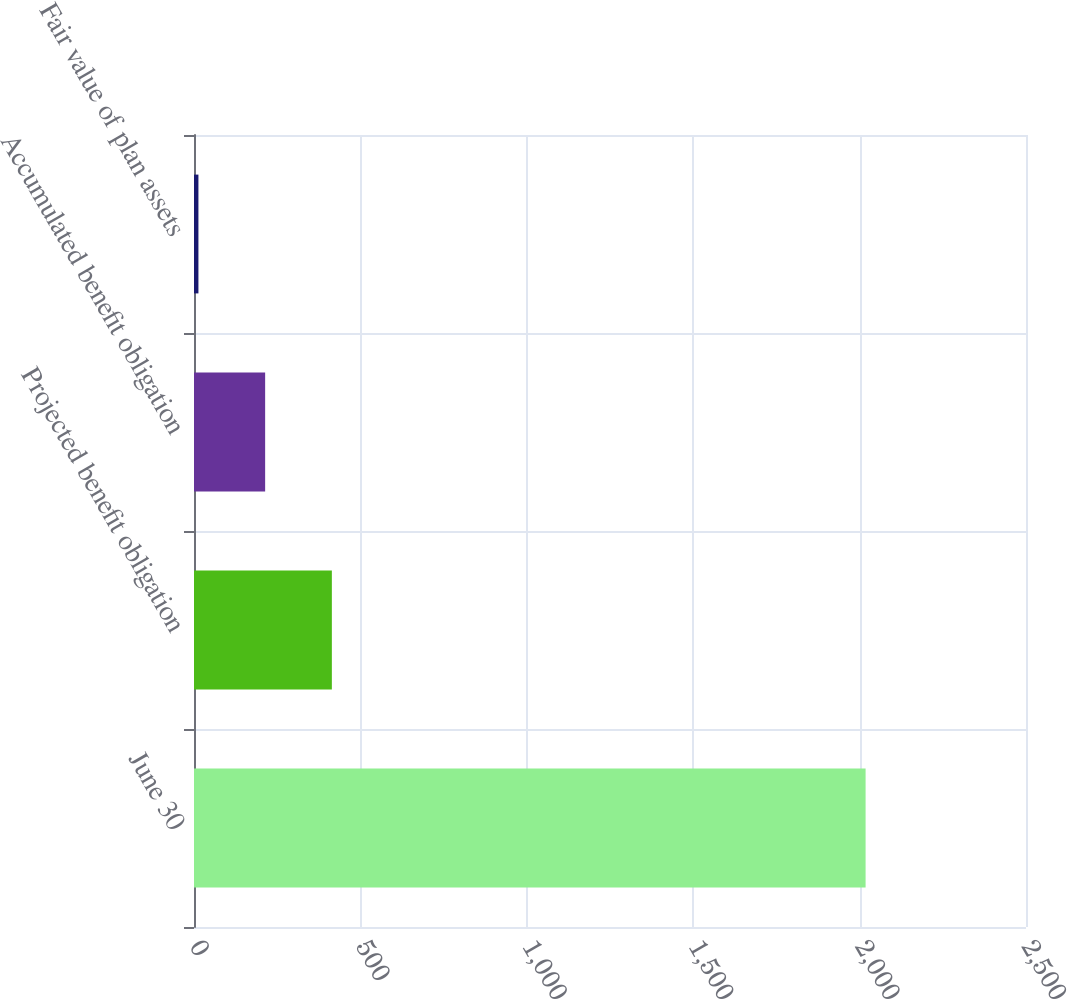<chart> <loc_0><loc_0><loc_500><loc_500><bar_chart><fcel>June 30<fcel>Projected benefit obligation<fcel>Accumulated benefit obligation<fcel>Fair value of plan assets<nl><fcel>2018<fcel>414.24<fcel>213.77<fcel>13.3<nl></chart> 